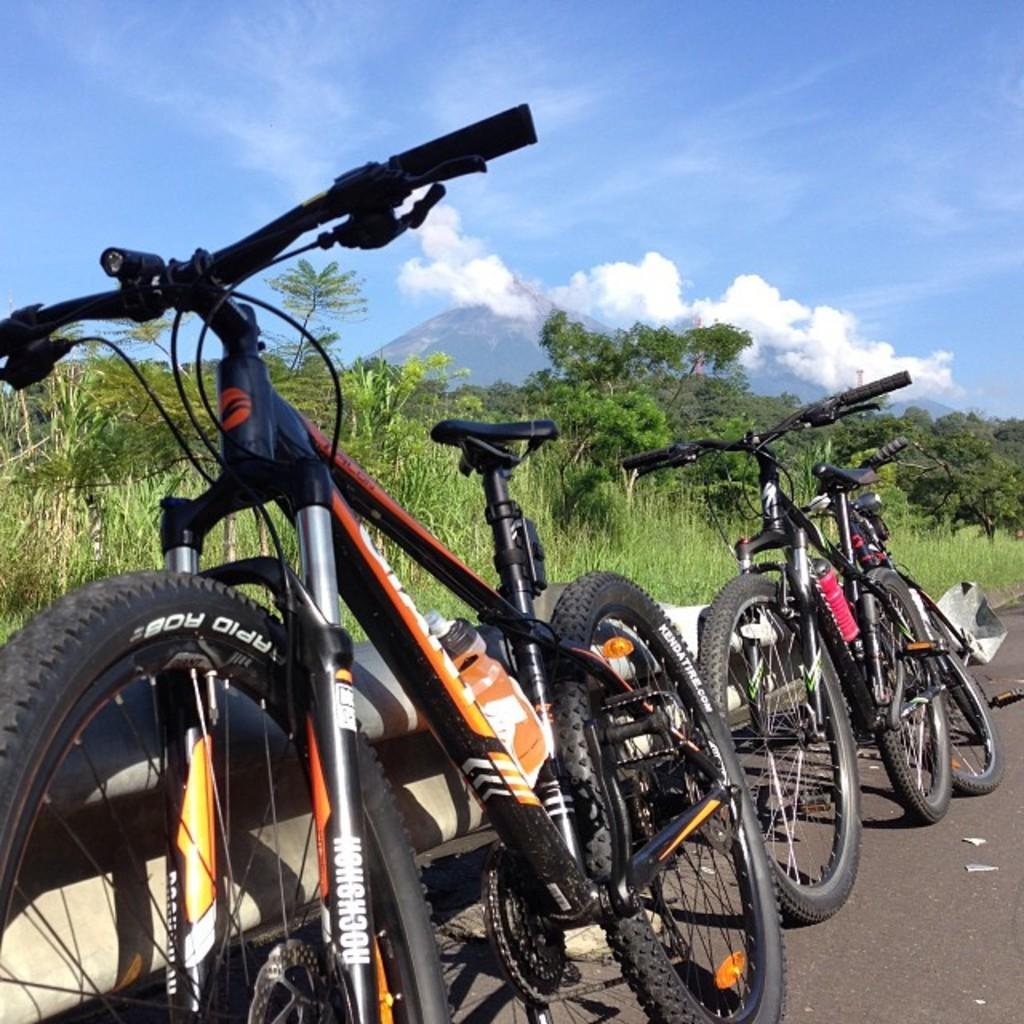How many bicycles can be seen in the image? There are two bicycles in the image. Where are the bicycles located? The bicycles are on the side of the road. What else can be seen in the image besides the bicycles? There are trees and the sky visible in the image. What is the condition of the sky in the image? Clouds are present in the sky. How many cows can be seen grazing in the image? There are no cows present in the image. What type of vein is visible on the bicycle tires in the image? There are no veins visible on the bicycle tires in the image. 